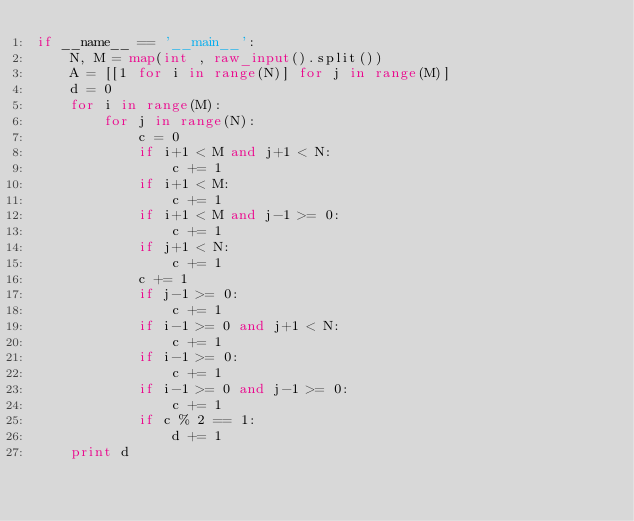<code> <loc_0><loc_0><loc_500><loc_500><_Python_>if __name__ == '__main__':
    N, M = map(int , raw_input().split())
    A = [[1 for i in range(N)] for j in range(M)]
    d = 0
    for i in range(M):
        for j in range(N):
            c = 0
            if i+1 < M and j+1 < N:
                c += 1
            if i+1 < M:
                c += 1
            if i+1 < M and j-1 >= 0:
                c += 1
            if j+1 < N:
                c += 1
            c += 1
            if j-1 >= 0:
                c += 1
            if i-1 >= 0 and j+1 < N:
                c += 1
            if i-1 >= 0:
                c += 1
            if i-1 >= 0 and j-1 >= 0:
                c += 1
            if c % 2 == 1:
                d += 1
    print d
</code> 